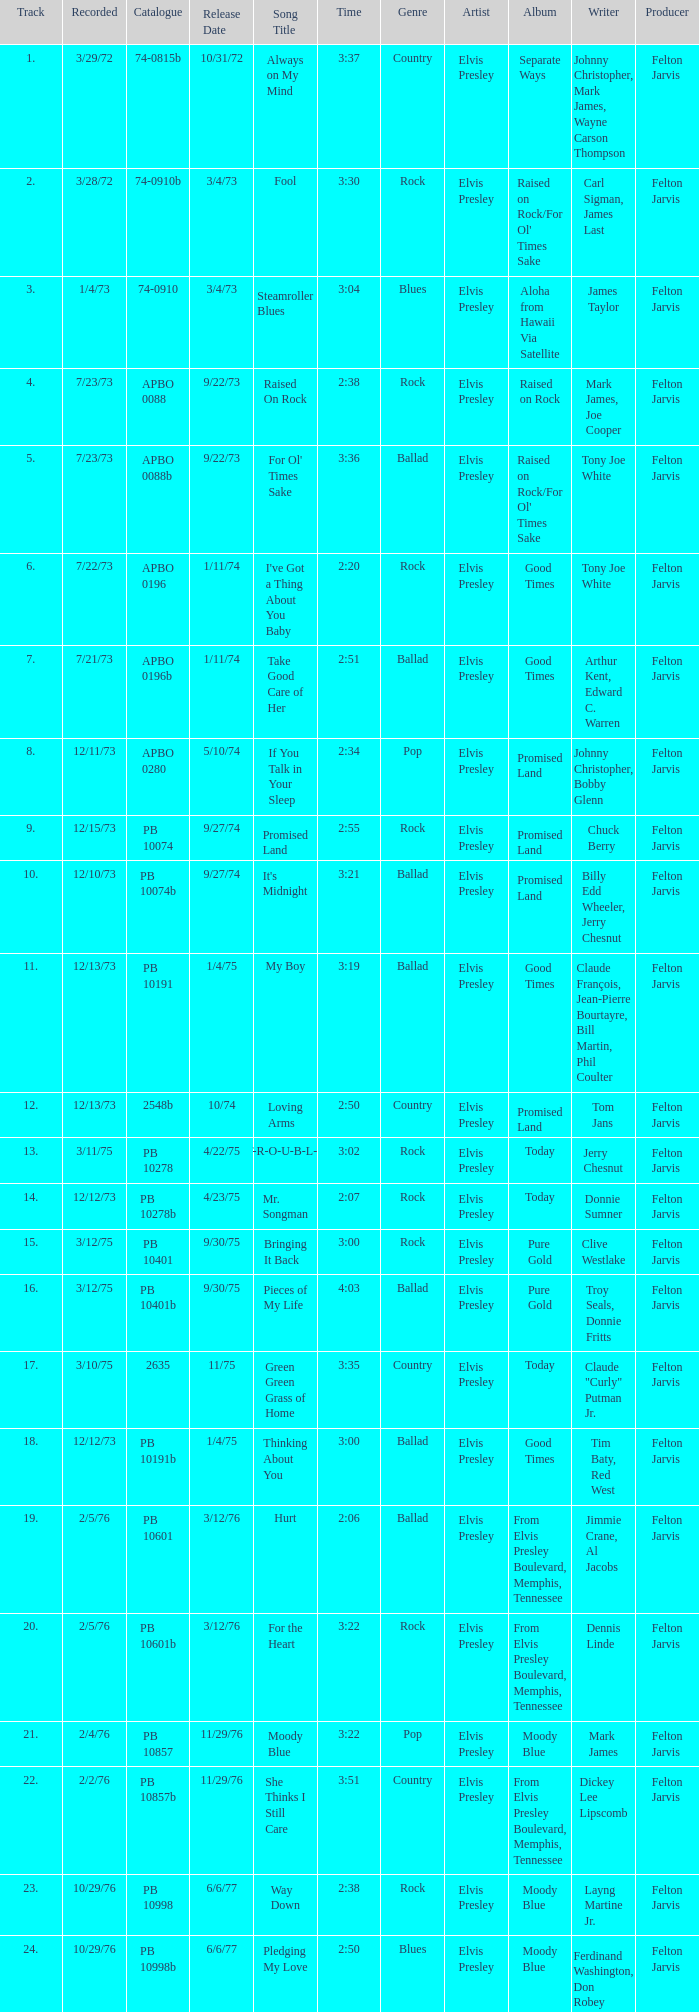Can you give me this table as a dict? {'header': ['Track', 'Recorded', 'Catalogue', 'Release Date', 'Song Title', 'Time', 'Genre', 'Artist', 'Album', 'Writer', 'Producer'], 'rows': [['1.', '3/29/72', '74-0815b', '10/31/72', 'Always on My Mind', '3:37', 'Country', 'Elvis Presley', 'Separate Ways', 'Johnny Christopher, Mark James, Wayne Carson Thompson', 'Felton Jarvis'], ['2.', '3/28/72', '74-0910b', '3/4/73', 'Fool', '3:30', 'Rock', 'Elvis Presley', "Raised on Rock/For Ol' Times Sake", 'Carl Sigman, James Last', 'Felton Jarvis'], ['3.', '1/4/73', '74-0910', '3/4/73', 'Steamroller Blues', '3:04', 'Blues', 'Elvis Presley', 'Aloha from Hawaii Via Satellite', 'James Taylor', 'Felton Jarvis'], ['4.', '7/23/73', 'APBO 0088', '9/22/73', 'Raised On Rock', '2:38', 'Rock', 'Elvis Presley', 'Raised on Rock', 'Mark James, Joe Cooper', 'Felton Jarvis'], ['5.', '7/23/73', 'APBO 0088b', '9/22/73', "For Ol' Times Sake", '3:36', 'Ballad', 'Elvis Presley', "Raised on Rock/For Ol' Times Sake", 'Tony Joe White', 'Felton Jarvis'], ['6.', '7/22/73', 'APBO 0196', '1/11/74', "I've Got a Thing About You Baby", '2:20', 'Rock', 'Elvis Presley', 'Good Times', 'Tony Joe White', 'Felton Jarvis'], ['7.', '7/21/73', 'APBO 0196b', '1/11/74', 'Take Good Care of Her', '2:51', 'Ballad', 'Elvis Presley', 'Good Times', 'Arthur Kent, Edward C. Warren', 'Felton Jarvis'], ['8.', '12/11/73', 'APBO 0280', '5/10/74', 'If You Talk in Your Sleep', '2:34', 'Pop', 'Elvis Presley', 'Promised Land', 'Johnny Christopher, Bobby Glenn', 'Felton Jarvis'], ['9.', '12/15/73', 'PB 10074', '9/27/74', 'Promised Land', '2:55', 'Rock', 'Elvis Presley', 'Promised Land', 'Chuck Berry', 'Felton Jarvis'], ['10.', '12/10/73', 'PB 10074b', '9/27/74', "It's Midnight", '3:21', 'Ballad', 'Elvis Presley', 'Promised Land', 'Billy Edd Wheeler, Jerry Chesnut', 'Felton Jarvis'], ['11.', '12/13/73', 'PB 10191', '1/4/75', 'My Boy', '3:19', 'Ballad', 'Elvis Presley', 'Good Times', 'Claude François, Jean-Pierre Bourtayre, Bill Martin, Phil Coulter', 'Felton Jarvis'], ['12.', '12/13/73', '2548b', '10/74', 'Loving Arms', '2:50', 'Country', 'Elvis Presley', 'Promised Land', 'Tom Jans', 'Felton Jarvis'], ['13.', '3/11/75', 'PB 10278', '4/22/75', 'T-R-O-U-B-L-E', '3:02', 'Rock', 'Elvis Presley', 'Today', 'Jerry Chesnut', 'Felton Jarvis'], ['14.', '12/12/73', 'PB 10278b', '4/23/75', 'Mr. Songman', '2:07', 'Rock', 'Elvis Presley', 'Today', 'Donnie Sumner', 'Felton Jarvis'], ['15.', '3/12/75', 'PB 10401', '9/30/75', 'Bringing It Back', '3:00', 'Rock', 'Elvis Presley', 'Pure Gold', 'Clive Westlake', 'Felton Jarvis'], ['16.', '3/12/75', 'PB 10401b', '9/30/75', 'Pieces of My Life', '4:03', 'Ballad', 'Elvis Presley', 'Pure Gold', 'Troy Seals, Donnie Fritts', 'Felton Jarvis '], ['17.', '3/10/75', '2635', '11/75', 'Green Green Grass of Home', '3:35', 'Country', 'Elvis Presley', 'Today', 'Claude "Curly" Putman Jr.', 'Felton Jarvis'], ['18.', '12/12/73', 'PB 10191b', '1/4/75', 'Thinking About You', '3:00', 'Ballad', 'Elvis Presley', 'Good Times', 'Tim Baty, Red West', 'Felton Jarvis'], ['19.', '2/5/76', 'PB 10601', '3/12/76', 'Hurt', '2:06', 'Ballad', 'Elvis Presley', 'From Elvis Presley Boulevard, Memphis, Tennessee', 'Jimmie Crane, Al Jacobs', 'Felton Jarvis '], ['20.', '2/5/76', 'PB 10601b', '3/12/76', 'For the Heart', '3:22', 'Rock', 'Elvis Presley', 'From Elvis Presley Boulevard, Memphis, Tennessee', 'Dennis Linde', 'Felton Jarvis'], ['21.', '2/4/76', 'PB 10857', '11/29/76', 'Moody Blue', '3:22', 'Pop', 'Elvis Presley', 'Moody Blue', 'Mark James', 'Felton Jarvis'], ['22.', '2/2/76', 'PB 10857b', '11/29/76', 'She Thinks I Still Care', '3:51', 'Country', 'Elvis Presley', 'From Elvis Presley Boulevard, Memphis, Tennessee', 'Dickey Lee Lipscomb', 'Felton Jarvis'], ['23.', '10/29/76', 'PB 10998', '6/6/77', 'Way Down', '2:38', 'Rock', 'Elvis Presley', 'Moody Blue', 'Layng Martine Jr.', 'Felton Jarvis'], ['24.', '10/29/76', 'PB 10998b', '6/6/77', 'Pledging My Love', '2:50', 'Blues', 'Elvis Presley', 'Moody Blue', 'Ferdinand Washington, Don Robey', 'Felton Jarvis']]} Tell me the release date record on 10/29/76 and a time on 2:50 6/6/77. 